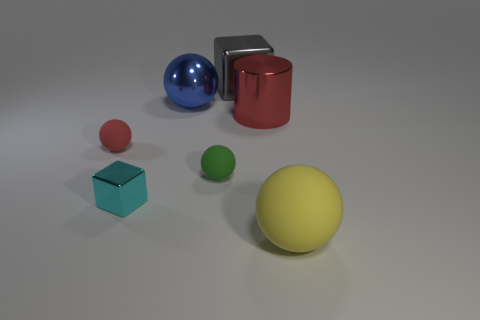Subtract all yellow balls. How many balls are left? 3 Add 1 large red cylinders. How many objects exist? 8 Subtract all blue spheres. How many spheres are left? 3 Subtract all blocks. How many objects are left? 5 Subtract all big green metallic balls. Subtract all balls. How many objects are left? 3 Add 4 metallic balls. How many metallic balls are left? 5 Add 1 large red metallic cylinders. How many large red metallic cylinders exist? 2 Subtract 0 brown spheres. How many objects are left? 7 Subtract 1 cylinders. How many cylinders are left? 0 Subtract all brown cylinders. Subtract all brown blocks. How many cylinders are left? 1 